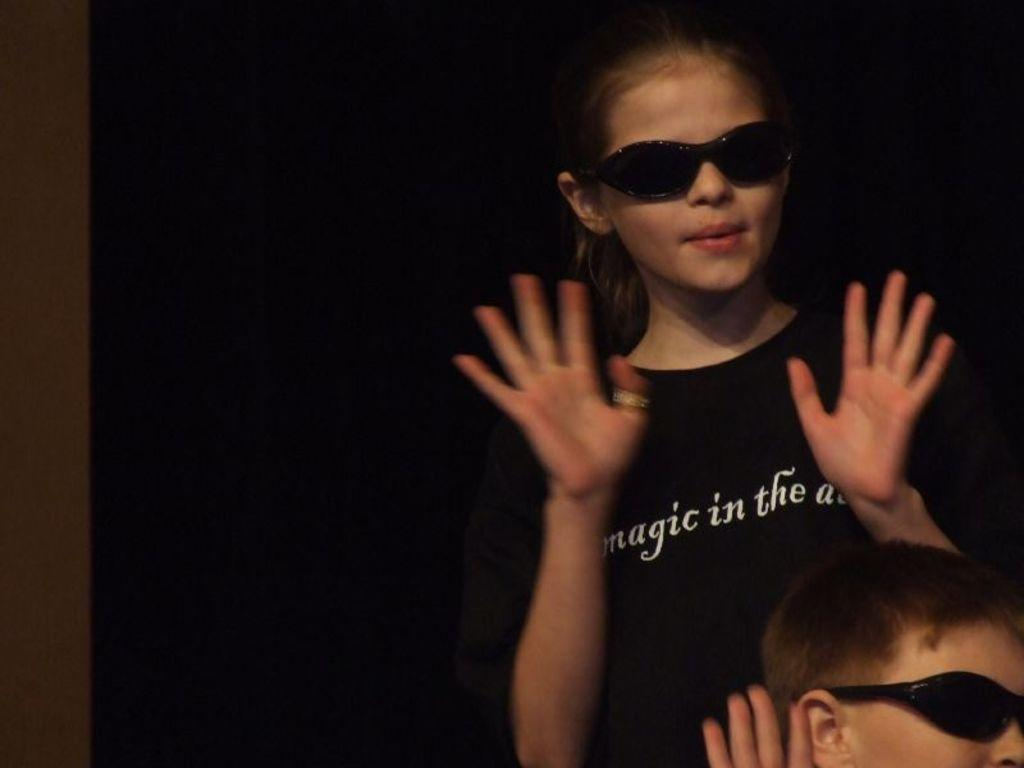How many people are in the image? There are two people in the image. What is the person in front wearing? The person in front is wearing a black color shirt. What can be observed about the background of the image? The background of the image is dark. What type of fork can be seen in the hands of the person in the image? There is no fork present in the image; both people are visible without any utensils. 